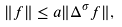Convert formula to latex. <formula><loc_0><loc_0><loc_500><loc_500>\| f \| \leq a \| \Delta ^ { \sigma } f \| ,</formula> 